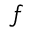<formula> <loc_0><loc_0><loc_500><loc_500>f</formula> 